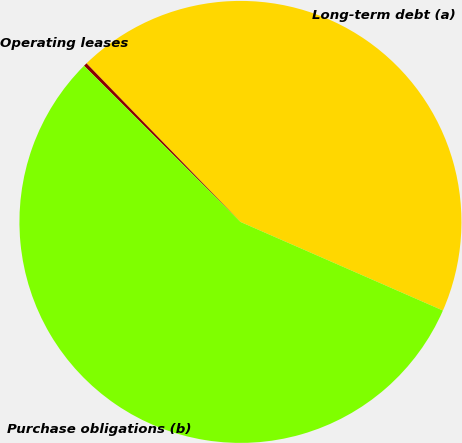<chart> <loc_0><loc_0><loc_500><loc_500><pie_chart><fcel>Long-term debt (a)<fcel>Operating leases<fcel>Purchase obligations (b)<nl><fcel>43.83%<fcel>0.25%<fcel>55.92%<nl></chart> 